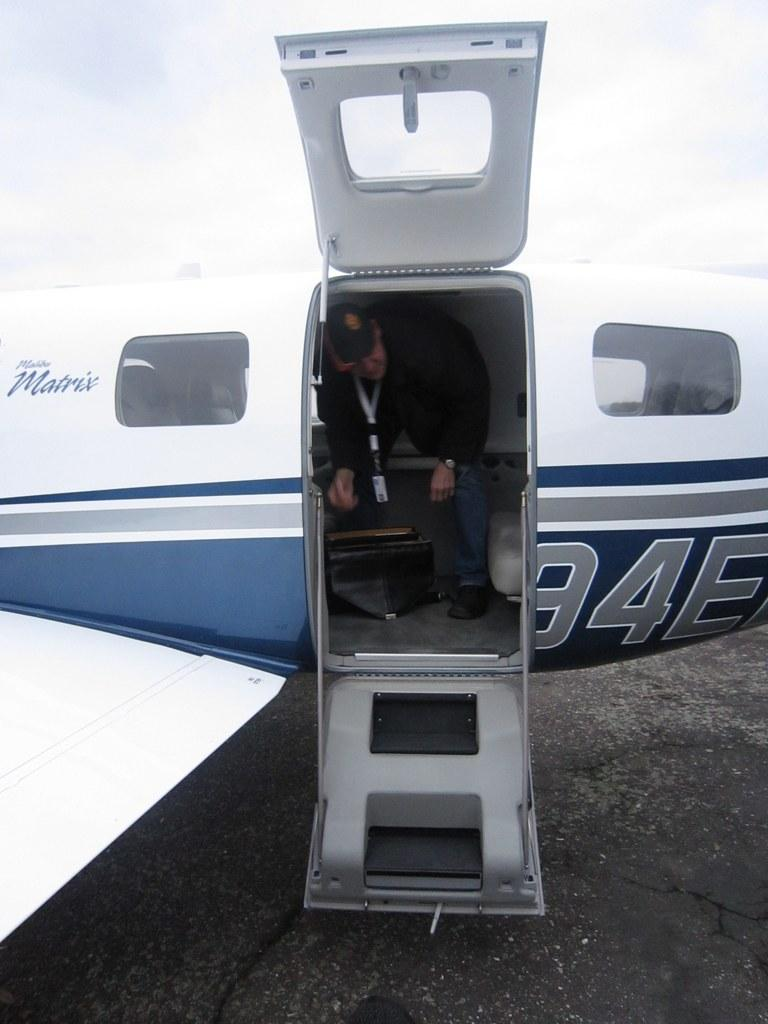What is the main subject of the picture? The main subject of the picture is an airplane. Can you describe the interior of the airplane? There is a person in the airplane, which suggests that the interior is visible. What is visible at the top of the image? The sky is visible at the top of the image. What type of island can be seen in the background of the image? There is no island present in the image; it features an airplane with a person inside. 